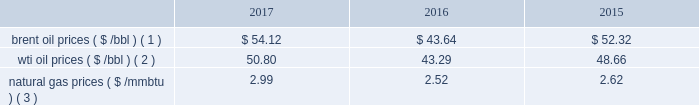Bhge 2017 form 10-k | 27 the short term .
We do , however , view the long term economics of the lng industry as positive given our outlook for supply and demand .
2022 refinery , petrochemical and industrial projects : in refining , we believe large , complex refineries should gain advantage in a more competitive , oversupplied landscape in 2018 as the industry globalizes and refiners position to meet local demand and secure export potential .
In petrochemicals , we continue to see healthy demand and cost-advantaged supply driving projects forward in 2018 .
The industrial market continues to grow as outdated infrastructure is replaced , policy changes come into effect and power is decentralized .
We continue to see growing demand across these markets in 2018 .
We have other segments in our portfolio that are more correlated with different industrial metrics such as our digital solutions business .
Overall , we believe our portfolio is uniquely positioned to compete across the value chain , and deliver unique solutions for our customers .
We remain optimistic about the long-term economics of the industry , but are continuing to operate with flexibility given our expectations for volatility and changing assumptions in the near term .
In 2016 , solar and wind net additions exceeded coal and gas for the first time and it continued throughout 2017 .
Governments may change or may not continue incentives for renewable energy additions .
In the long term , renewables' cost decline may accelerate to compete with new-built fossil capacity , however , we do not anticipate any significant impacts to our business in the foreseeable future .
Despite the near-term volatility , the long-term outlook for our industry remains strong .
We believe the world 2019s demand for energy will continue to rise , and the supply of energy will continue to increase in complexity , requiring greater service intensity and more advanced technology from oilfield service companies .
As such , we remain focused on delivering innovative cost-efficient solutions that deliver step changes in operating and economic performance for our customers .
Business environment the following discussion and analysis summarizes the significant factors affecting our results of operations , financial condition and liquidity position as of and for the year ended december 31 , 2017 , 2016 and 2015 , and should be read in conjunction with the consolidated and combined financial statements and related notes of the company .
Amounts reported in millions in graphs within this report are computed based on the amounts in hundreds .
As a result , the sum of the components reported in millions may not equal the total amount reported in millions due to rounding .
We operate in more than 120 countries helping customers find , evaluate , drill , produce , transport and process hydrocarbon resources .
Our revenue is predominately generated from the sale of products and services to major , national , and independent oil and natural gas companies worldwide , and is dependent on spending by our customers for oil and natural gas exploration , field development and production .
This spending is driven by a number of factors , including our customers' forecasts of future energy demand and supply , their access to resources to develop and produce oil and natural gas , their ability to fund their capital programs , the impact of new government regulations and most importantly , their expectations for oil and natural gas prices as a key driver of their cash flows .
Oil and natural gas prices oil and natural gas prices are summarized in the table below as averages of the daily closing prices during each of the periods indicated. .
Brent oil prices ( $ /bbl ) ( 1 ) $ 54.12 $ 43.64 $ 52.32 wti oil prices ( $ /bbl ) ( 2 ) 50.80 43.29 48.66 natural gas prices ( $ /mmbtu ) ( 3 ) 2.99 2.52 2.62 ( 1 ) energy information administration ( eia ) europe brent spot price per barrel .
What are the natural gas prices as a percentage of wti oil prices in 2016? 
Computations: (2.52 / 43.29)
Answer: 0.05821. 